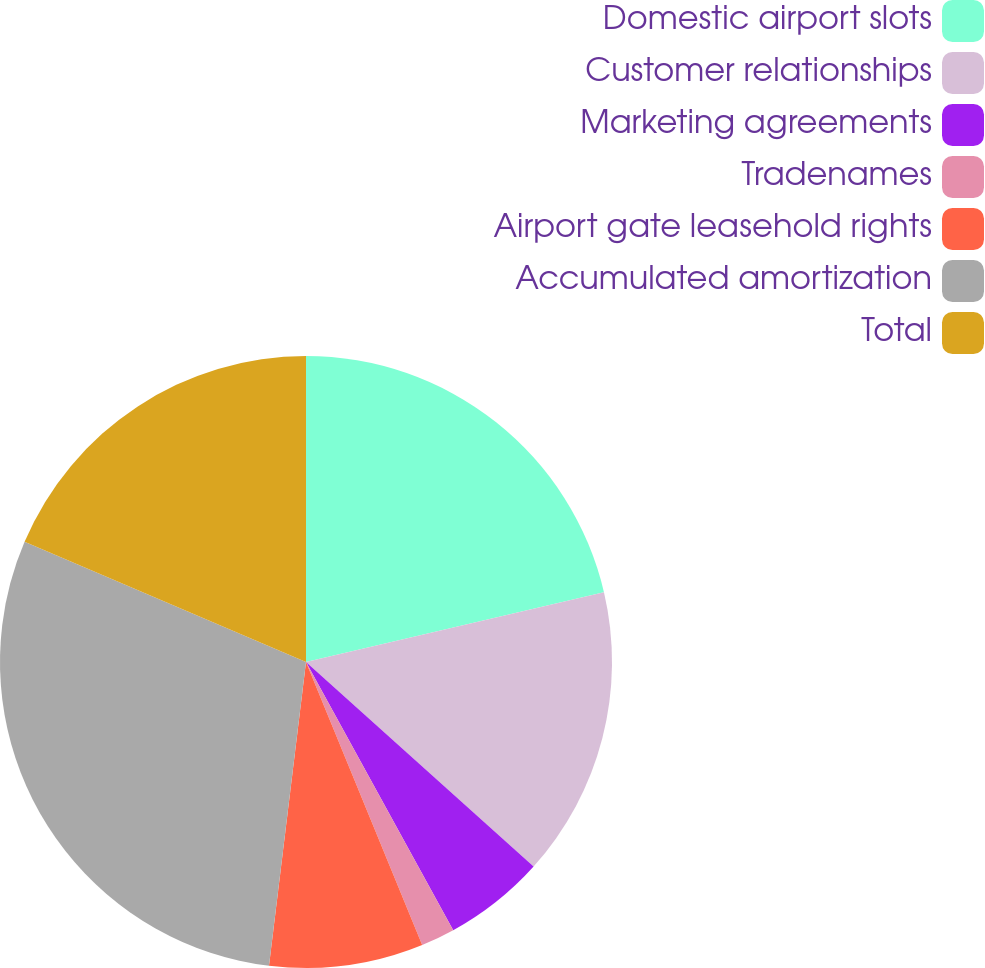Convert chart. <chart><loc_0><loc_0><loc_500><loc_500><pie_chart><fcel>Domestic airport slots<fcel>Customer relationships<fcel>Marketing agreements<fcel>Tradenames<fcel>Airport gate leasehold rights<fcel>Accumulated amortization<fcel>Total<nl><fcel>21.35%<fcel>15.31%<fcel>5.36%<fcel>1.79%<fcel>8.13%<fcel>29.5%<fcel>18.58%<nl></chart> 